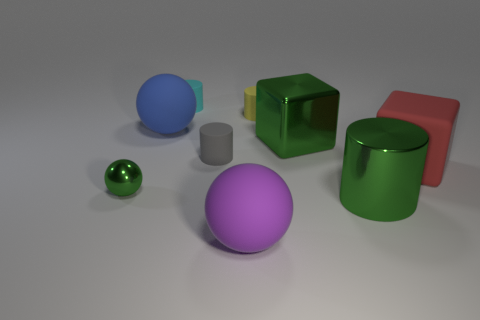There is a large cube that is the same color as the metal ball; what is its material?
Your response must be concise. Metal. Is the color of the block on the left side of the large metallic cylinder the same as the big cylinder?
Your answer should be compact. Yes. There is a small shiny thing that is the same color as the big shiny cube; what shape is it?
Your response must be concise. Sphere. What number of other tiny cyan things are the same shape as the tiny cyan rubber object?
Your answer should be very brief. 0. The metallic block that is the same size as the rubber cube is what color?
Provide a short and direct response. Green. Are any tiny green metal spheres visible?
Ensure brevity in your answer.  Yes. There is a green object that is on the right side of the green block; what shape is it?
Provide a succinct answer. Cylinder. What number of things are both behind the green shiny cylinder and to the left of the green shiny block?
Your answer should be very brief. 5. Are there any small gray objects made of the same material as the big blue ball?
Give a very brief answer. Yes. There is a cylinder that is the same color as the shiny sphere; what size is it?
Your answer should be very brief. Large. 